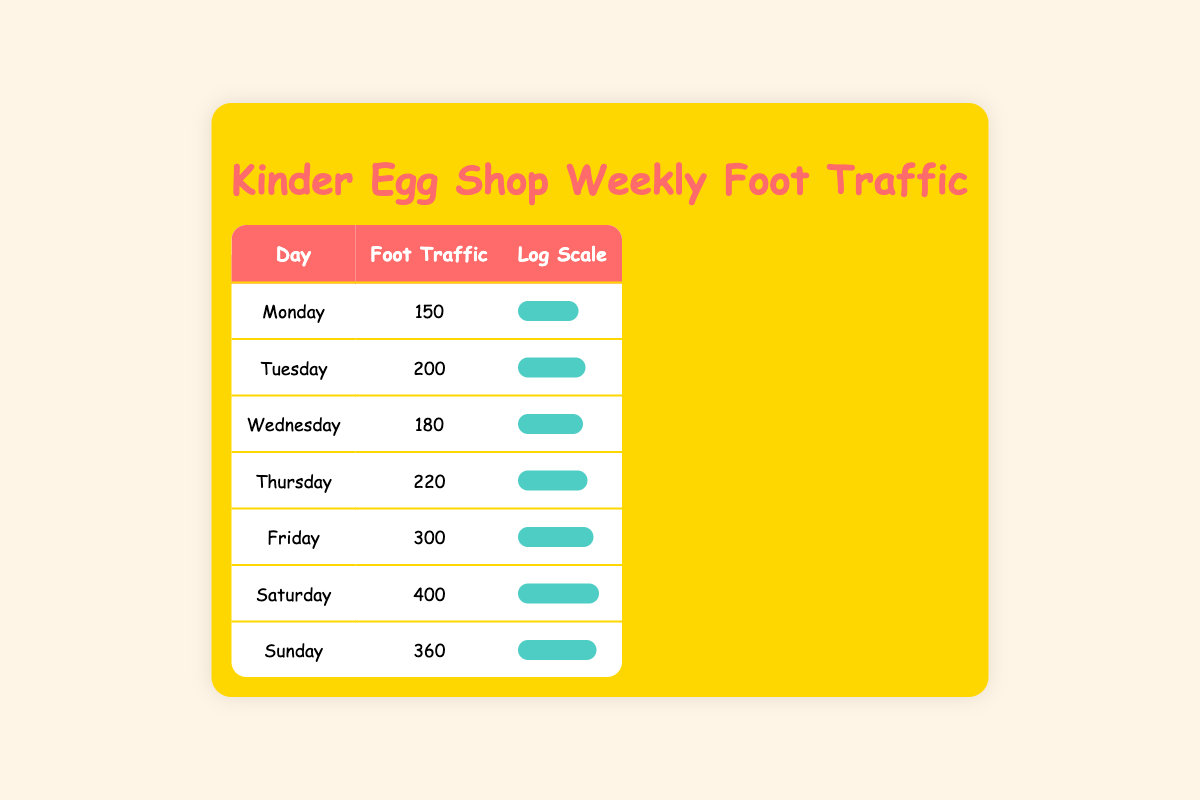What day had the highest foot traffic? By looking at the 'Foot Traffic' column, we can see that Saturday has the highest value at 400.
Answer: Saturday What is the foot traffic on Wednesday? The foot traffic for Wednesday is directly provided in the table, which shows a value of 180.
Answer: 180 What is the total foot traffic for the week? To find the total foot traffic, we sum all the daily foot traffic values: 150 + 200 + 180 + 220 + 300 + 400 + 360 = 1880.
Answer: 1880 Is the foot traffic on Sunday greater than that on Tuesday? We compare the values of Sunday (360) and Tuesday (200). Since 360 is greater than 200, the statement is true.
Answer: Yes What is the average foot traffic for the weekdays (Monday to Friday)? First, we calculate the total foot traffic for the weekdays: 150 + 200 + 180 + 220 + 300 = 1050. There are 5 weekdays, so the average is 1050 divided by 5, which equals 210.
Answer: 210 Which day has foot traffic lower than 200? We can look at the 'Foot Traffic' values and see that only Monday (150) and Wednesday (180) have values lower than 200.
Answer: Monday and Wednesday What is the difference in foot traffic between Friday and Saturday? We find the foot traffic for Friday (300) and Saturday (400). The difference is calculated by subtracting Friday's value from Saturday's: 400 - 300 = 100.
Answer: 100 How many days had foot traffic above 300? We check the 'Foot Traffic' values: Saturday (400) and Sunday (360) are the only days above 300, totaling 2 days.
Answer: 2 What is the median foot traffic for the week? First, we list the foot traffic values in order: 150, 180, 200, 220, 300, 360, 400. There are 7 values, so the median is the fourth value, which is 220.
Answer: 220 